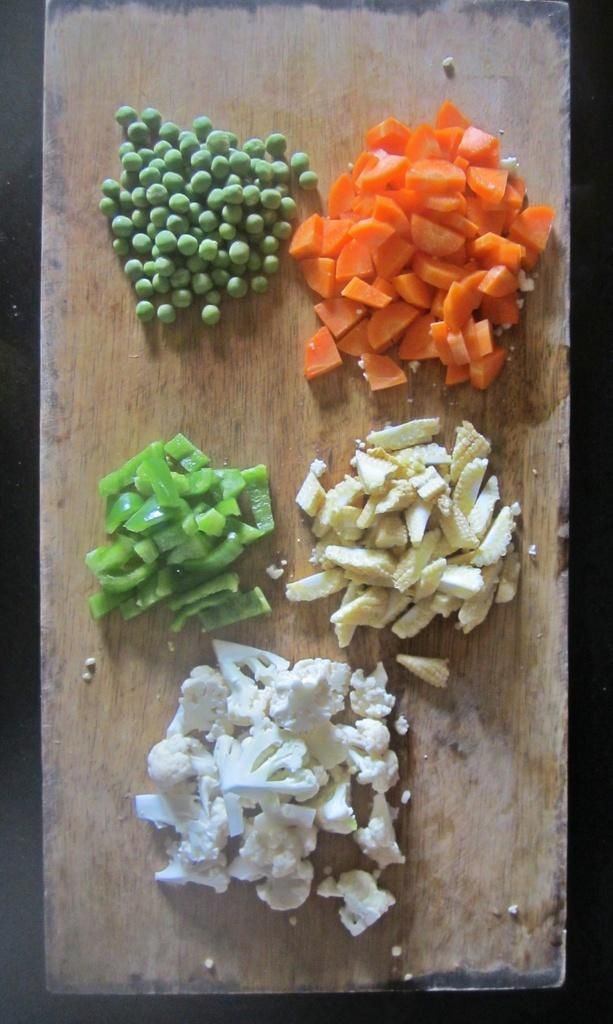What type of food can be seen in the image? There are green peas in the image. What activity is being performed with the vegetables in the image? Vegetables are being chopped on a chopping board in the image. Where is the playground located in the image? There is no playground present in the image. What is the limit of the vegetables being chopped in the image? The image does not specify a limit for the vegetables being chopped. 